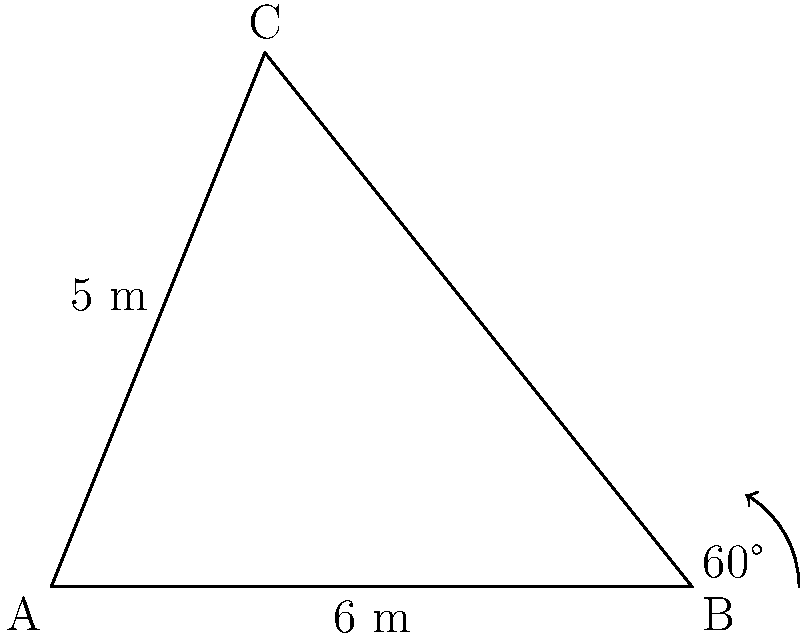At a local music festival in Greece, organizers are setting up a triangular stage. Two sides of the stage measure 5 meters and 6 meters, with an angle of 60° between them. What is the area of this triangular stage in square meters? To find the area of the triangular stage, we can use the formula for the area of a triangle given two sides and the included angle:

$$ A = \frac{1}{2} ab \sin C $$

Where:
- $A$ is the area of the triangle
- $a$ and $b$ are the lengths of the two known sides
- $C$ is the angle between these sides

Given:
- $a = 5$ meters
- $b = 6$ meters
- $C = 60°$

Step 1: Substitute the values into the formula:
$$ A = \frac{1}{2} \cdot 5 \cdot 6 \cdot \sin 60° $$

Step 2: Calculate $\sin 60°$:
$\sin 60° = \frac{\sqrt{3}}{2}$

Step 3: Substitute this value and calculate:
$$ A = \frac{1}{2} \cdot 5 \cdot 6 \cdot \frac{\sqrt{3}}{2} $$
$$ A = \frac{15\sqrt{3}}{2} $$

Step 4: Simplify and round to two decimal places:
$$ A \approx 12.99 \text{ m}^2 $$

Therefore, the area of the triangular stage is approximately 12.99 square meters.
Answer: $12.99 \text{ m}^2$ 